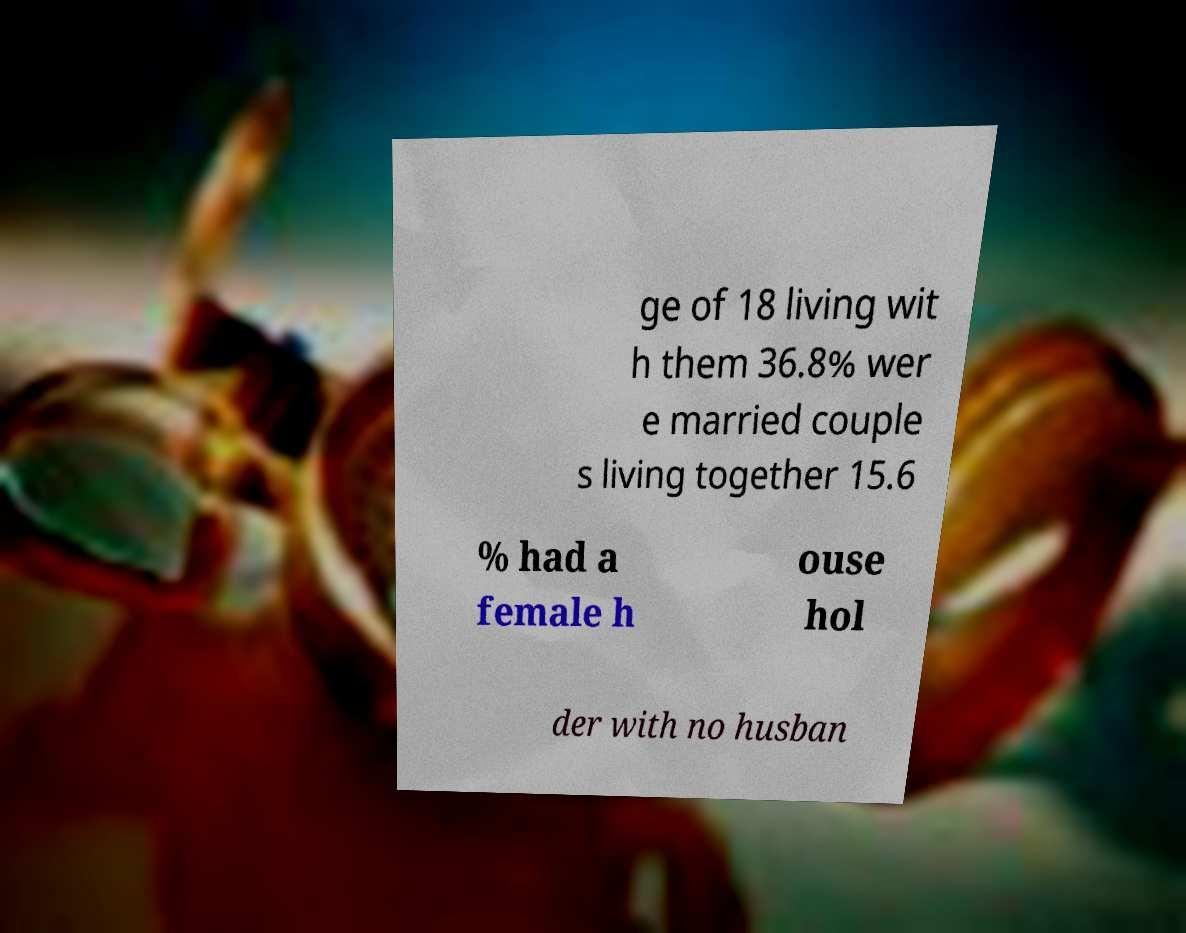Could you assist in decoding the text presented in this image and type it out clearly? ge of 18 living wit h them 36.8% wer e married couple s living together 15.6 % had a female h ouse hol der with no husban 